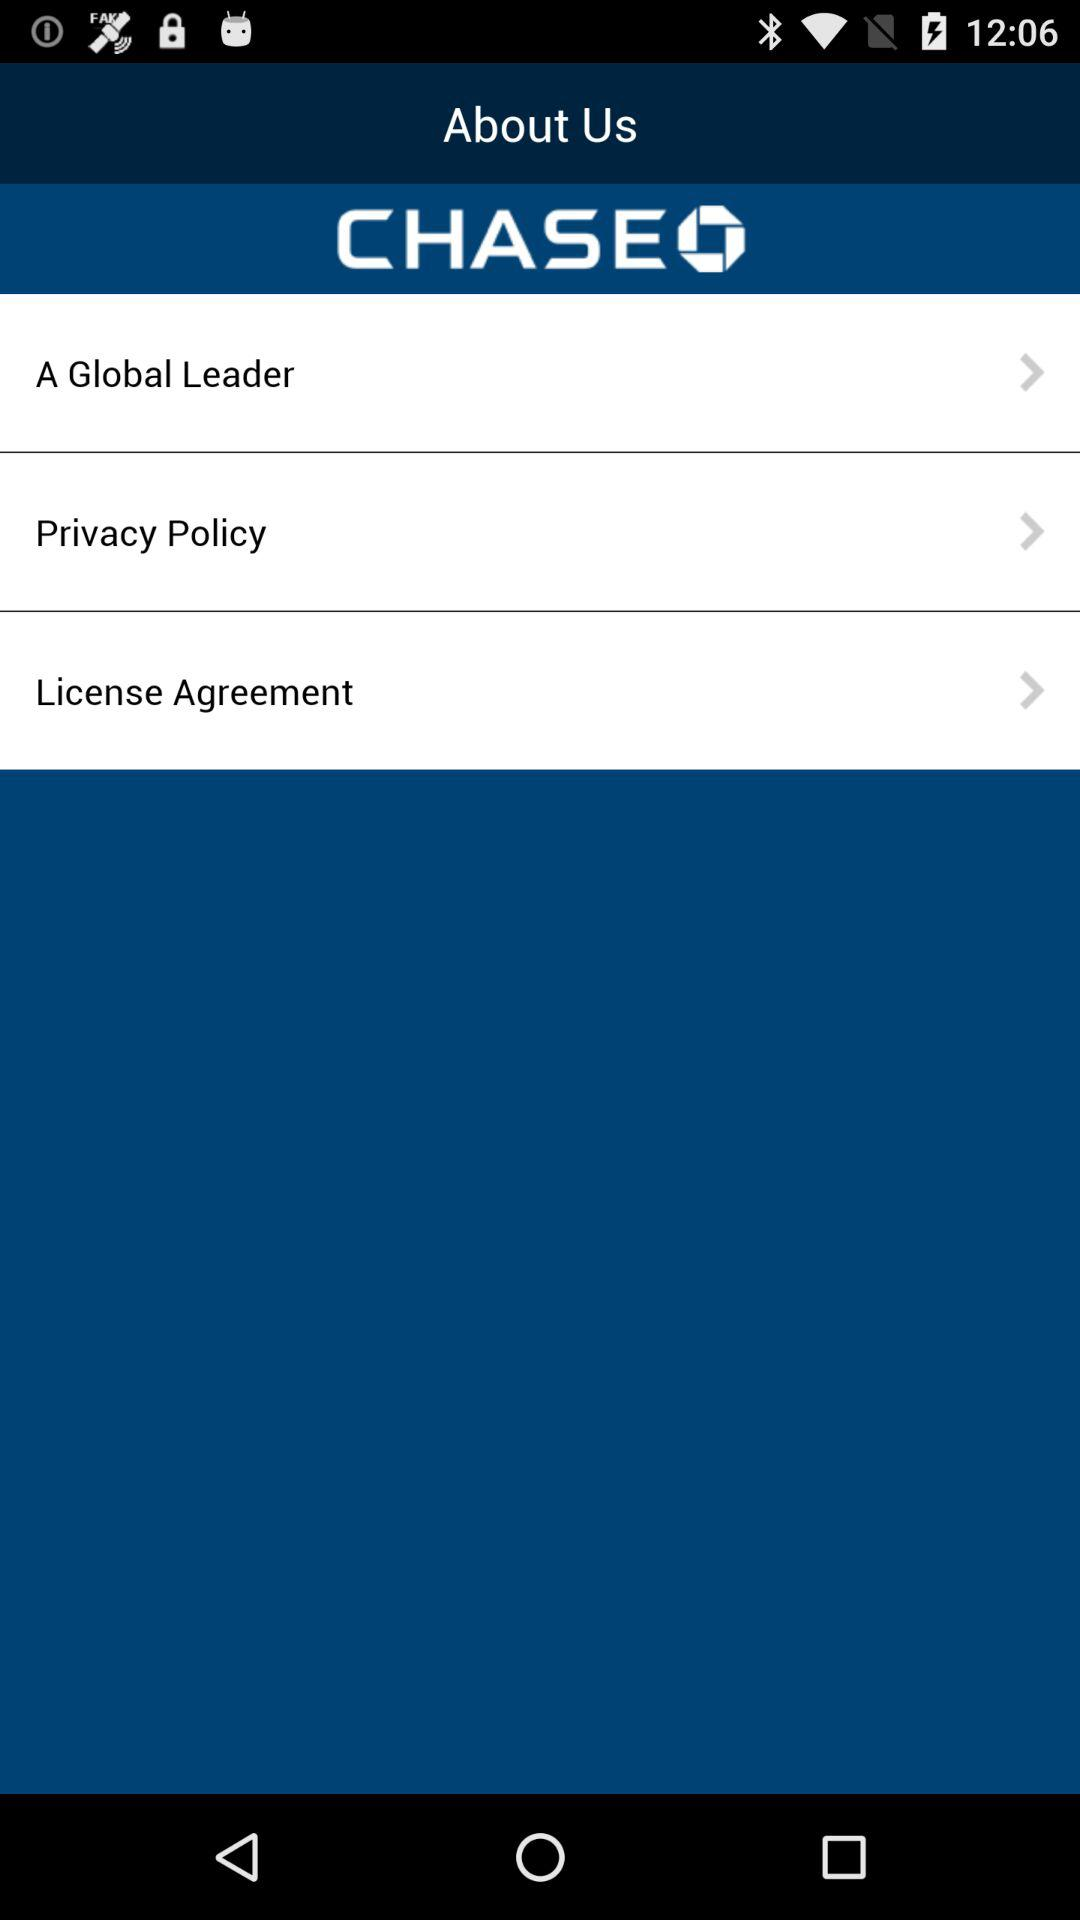What is the name of the application? The application name is "CHASEO". 